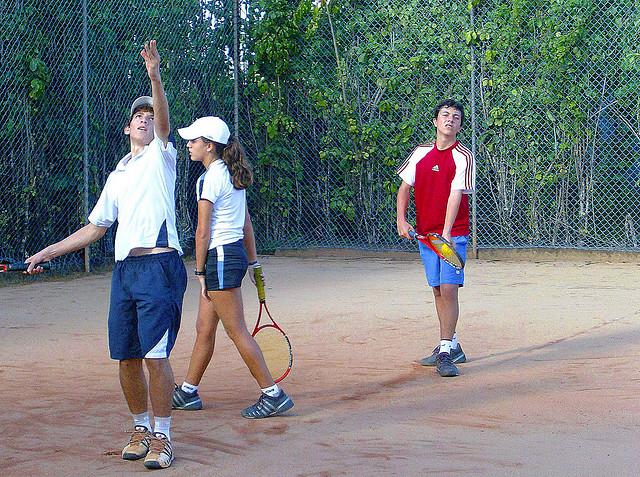What type of shoes are the people wearing?
Write a very short answer. Tennis. How many people are there?
Concise answer only. 3. What type of shirt is the man wearing?
Be succinct. T shirt. Is the boy having fun?
Keep it brief. Yes. 